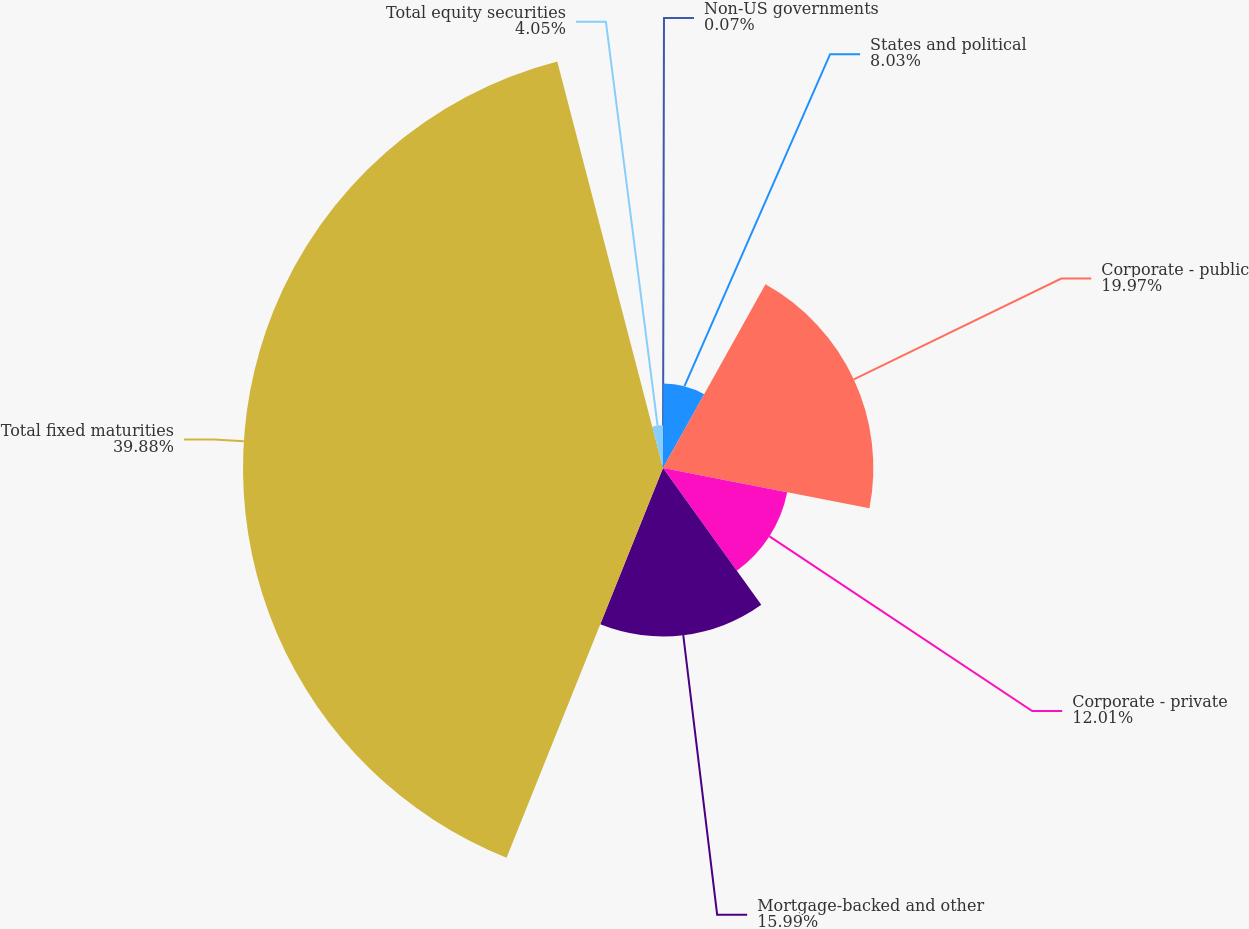<chart> <loc_0><loc_0><loc_500><loc_500><pie_chart><fcel>Non-US governments<fcel>States and political<fcel>Corporate - public<fcel>Corporate - private<fcel>Mortgage-backed and other<fcel>Total fixed maturities<fcel>Total equity securities<nl><fcel>0.07%<fcel>8.03%<fcel>19.97%<fcel>12.01%<fcel>15.99%<fcel>39.87%<fcel>4.05%<nl></chart> 